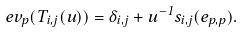Convert formula to latex. <formula><loc_0><loc_0><loc_500><loc_500>\ e v _ { p } ( T _ { i , j } ( u ) ) = \delta _ { i , j } + u ^ { - 1 } s _ { i , j } ( e _ { p , p } ) .</formula> 